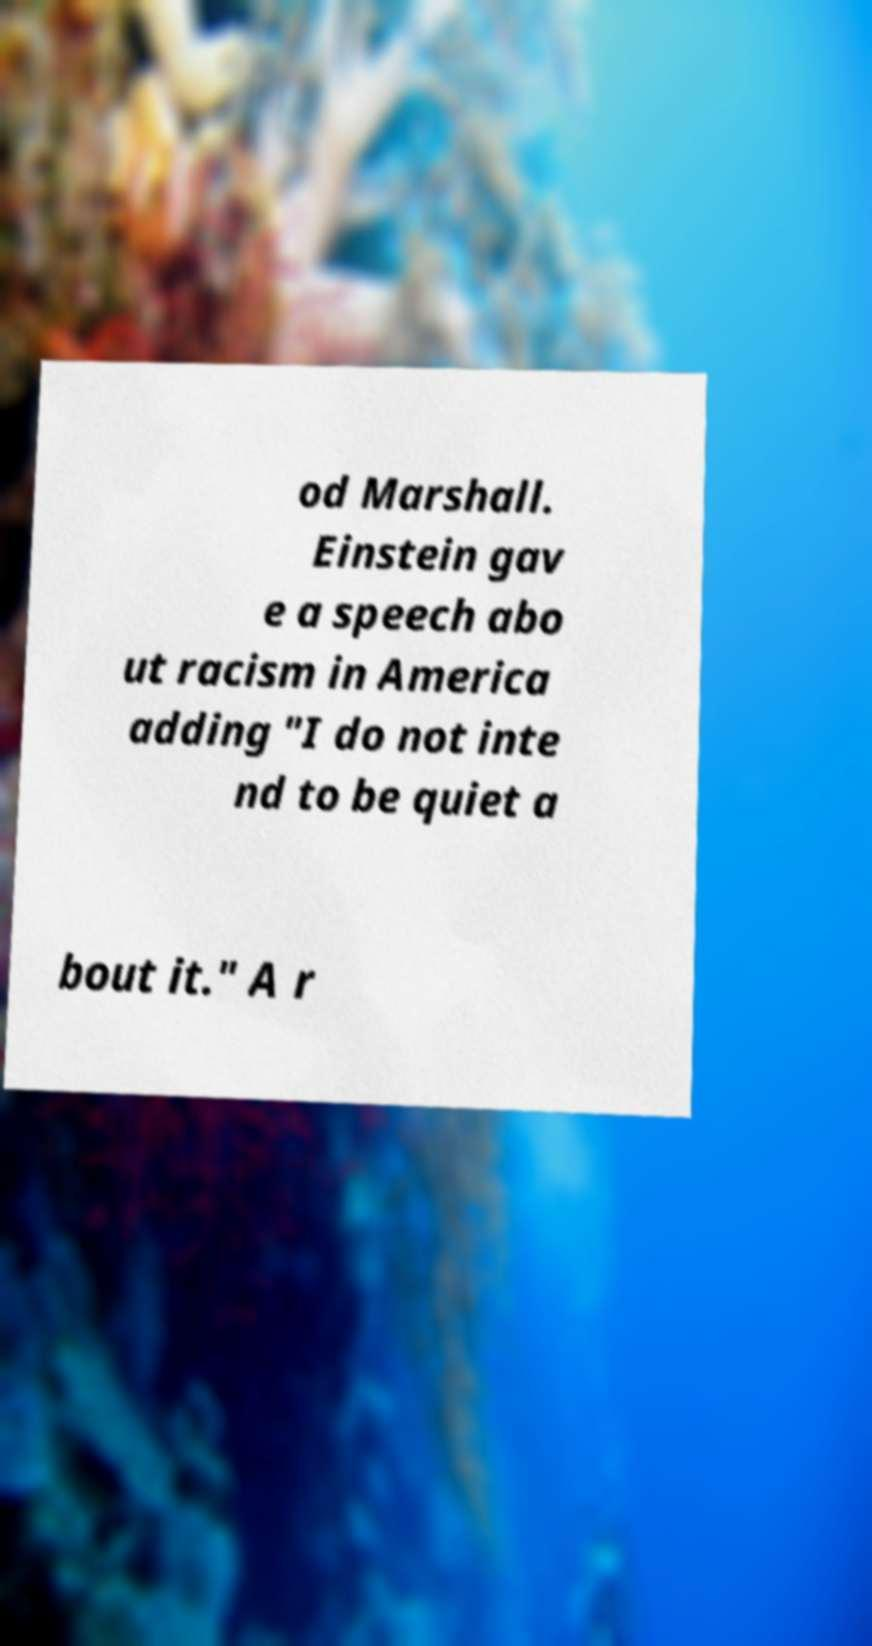Please read and relay the text visible in this image. What does it say? od Marshall. Einstein gav e a speech abo ut racism in America adding "I do not inte nd to be quiet a bout it." A r 